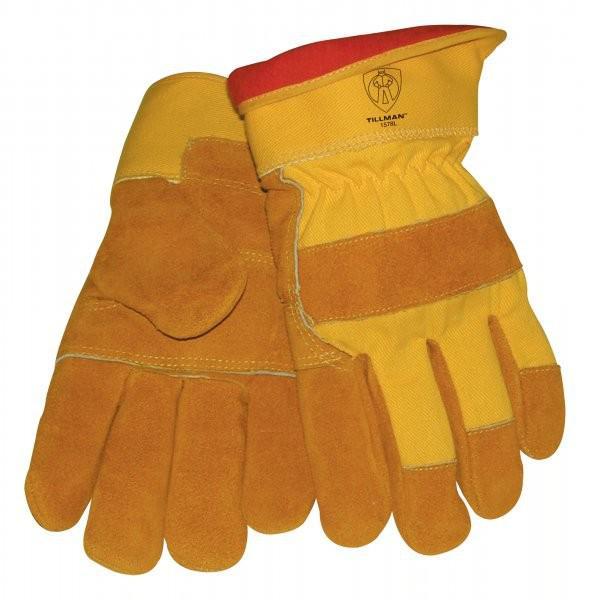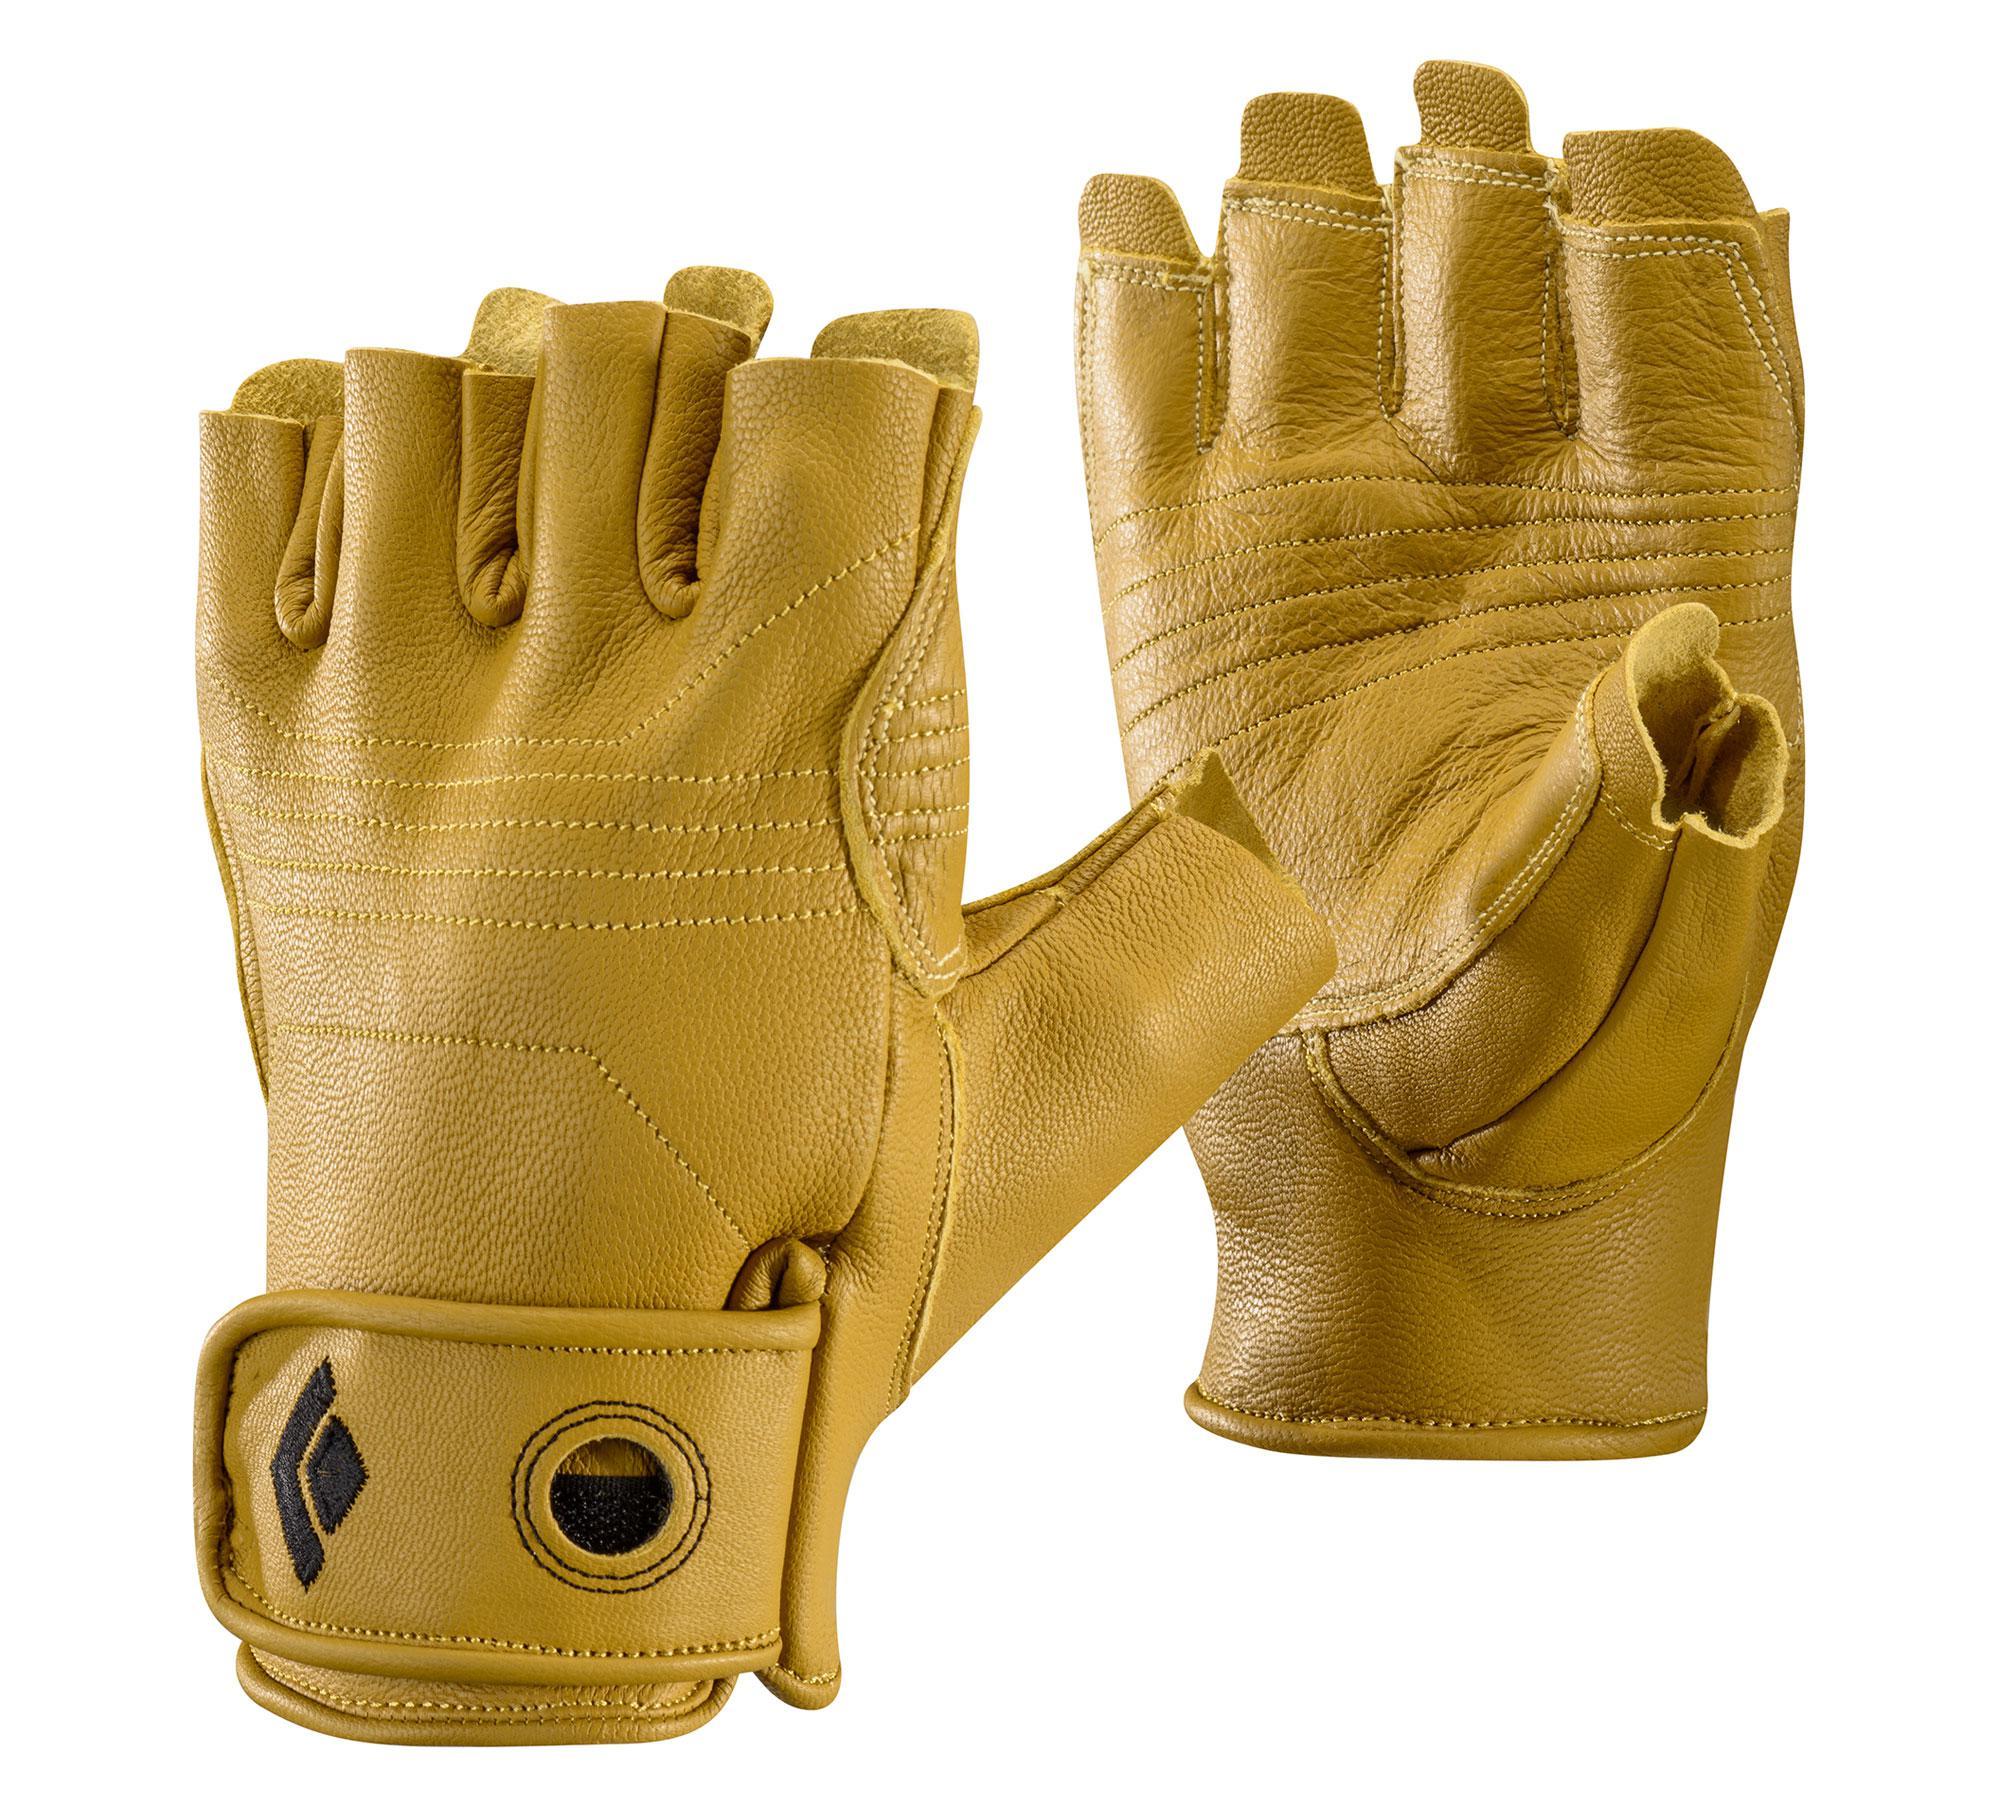The first image is the image on the left, the second image is the image on the right. For the images displayed, is the sentence "Both images show the front and back side of a pair of gloves." factually correct? Answer yes or no. Yes. 